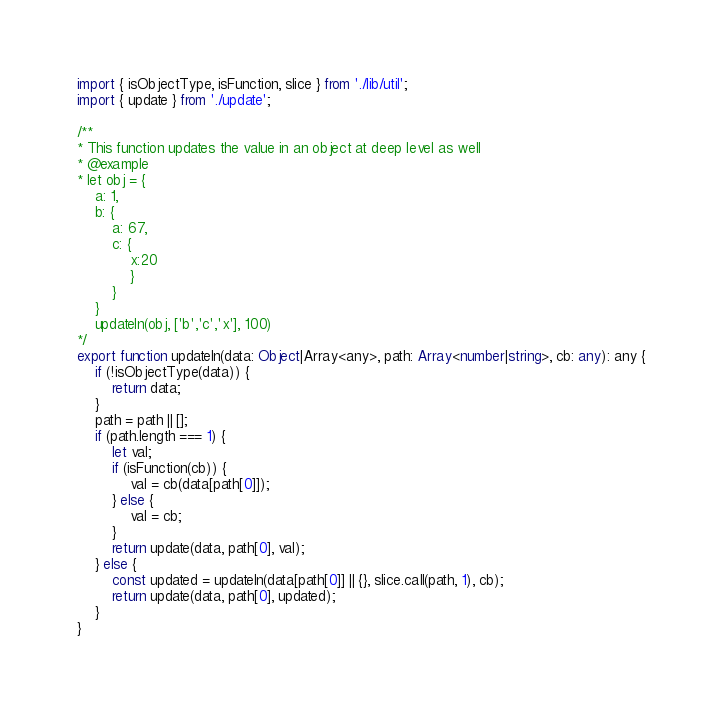<code> <loc_0><loc_0><loc_500><loc_500><_TypeScript_>import { isObjectType, isFunction, slice } from './lib/util';
import { update } from './update';

/**
* This function updates the value in an object at deep level as well
* @example
* let obj = {
    a: 1,
    b: {
        a: 67,
        c: {
            x:20
            }
        }
    }
    updateIn(obj, ['b','c','x'], 100)
*/
export function updateIn(data: Object|Array<any>, path: Array<number|string>, cb: any): any {
    if (!isObjectType(data)) {
        return data;
    }
    path = path || [];
    if (path.length === 1) {
        let val;
        if (isFunction(cb)) {
            val = cb(data[path[0]]);
        } else {
            val = cb;
        }
        return update(data, path[0], val);
    } else {
        const updated = updateIn(data[path[0]] || {}, slice.call(path, 1), cb);
        return update(data, path[0], updated);
    }
}</code> 